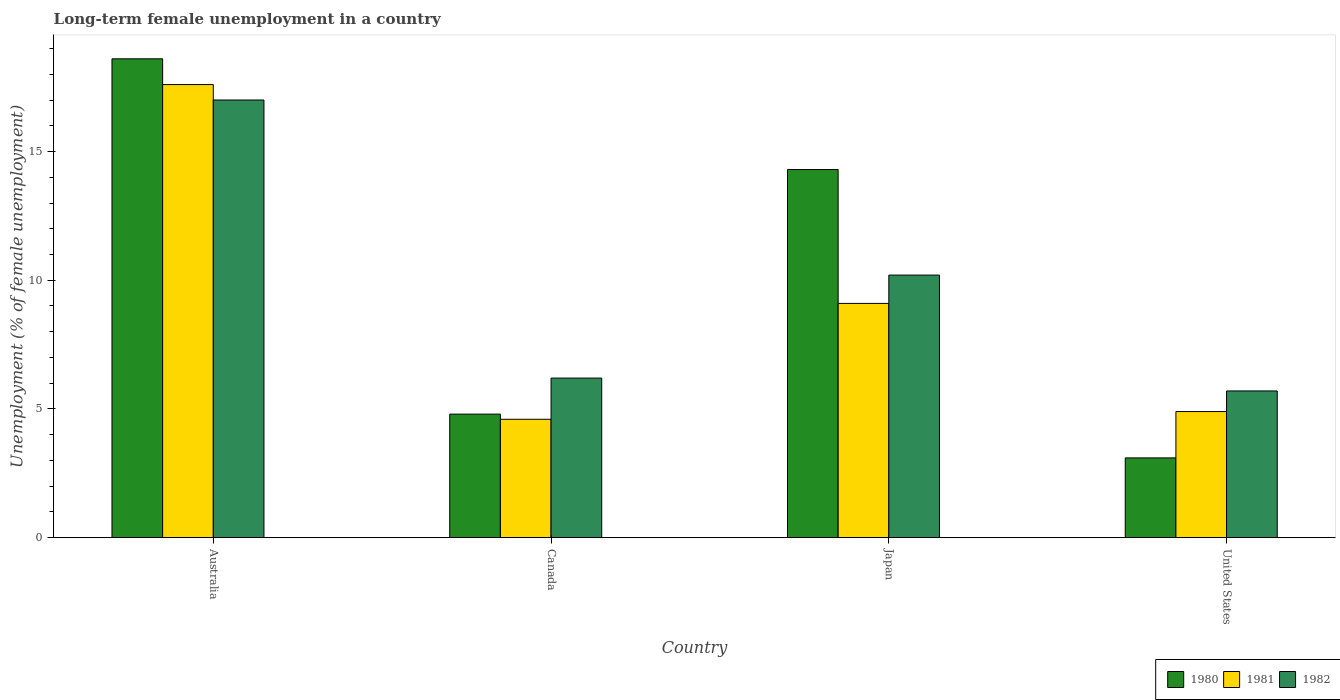Are the number of bars per tick equal to the number of legend labels?
Ensure brevity in your answer.  Yes. In how many cases, is the number of bars for a given country not equal to the number of legend labels?
Keep it short and to the point. 0. What is the percentage of long-term unemployed female population in 1980 in United States?
Offer a very short reply. 3.1. Across all countries, what is the minimum percentage of long-term unemployed female population in 1982?
Your answer should be very brief. 5.7. In which country was the percentage of long-term unemployed female population in 1982 minimum?
Provide a succinct answer. United States. What is the total percentage of long-term unemployed female population in 1982 in the graph?
Offer a terse response. 39.1. What is the difference between the percentage of long-term unemployed female population in 1980 in Canada and that in United States?
Provide a short and direct response. 1.7. What is the difference between the percentage of long-term unemployed female population in 1981 in Canada and the percentage of long-term unemployed female population in 1982 in Australia?
Provide a short and direct response. -12.4. What is the average percentage of long-term unemployed female population in 1982 per country?
Make the answer very short. 9.77. What is the difference between the percentage of long-term unemployed female population of/in 1982 and percentage of long-term unemployed female population of/in 1981 in Australia?
Ensure brevity in your answer.  -0.6. What is the ratio of the percentage of long-term unemployed female population in 1980 in Australia to that in United States?
Provide a short and direct response. 6. What is the difference between the highest and the second highest percentage of long-term unemployed female population in 1982?
Your answer should be very brief. 6.8. What is the difference between the highest and the lowest percentage of long-term unemployed female population in 1981?
Your response must be concise. 13. Is the sum of the percentage of long-term unemployed female population in 1982 in Canada and United States greater than the maximum percentage of long-term unemployed female population in 1980 across all countries?
Offer a terse response. No. What does the 3rd bar from the left in Japan represents?
Ensure brevity in your answer.  1982. Is it the case that in every country, the sum of the percentage of long-term unemployed female population in 1980 and percentage of long-term unemployed female population in 1981 is greater than the percentage of long-term unemployed female population in 1982?
Your response must be concise. Yes. How many bars are there?
Keep it short and to the point. 12. Does the graph contain grids?
Offer a very short reply. No. How many legend labels are there?
Your answer should be compact. 3. How are the legend labels stacked?
Your response must be concise. Horizontal. What is the title of the graph?
Provide a succinct answer. Long-term female unemployment in a country. What is the label or title of the Y-axis?
Provide a succinct answer. Unemployment (% of female unemployment). What is the Unemployment (% of female unemployment) in 1980 in Australia?
Keep it short and to the point. 18.6. What is the Unemployment (% of female unemployment) in 1981 in Australia?
Keep it short and to the point. 17.6. What is the Unemployment (% of female unemployment) in 1980 in Canada?
Provide a short and direct response. 4.8. What is the Unemployment (% of female unemployment) of 1981 in Canada?
Provide a short and direct response. 4.6. What is the Unemployment (% of female unemployment) in 1982 in Canada?
Your response must be concise. 6.2. What is the Unemployment (% of female unemployment) of 1980 in Japan?
Your answer should be very brief. 14.3. What is the Unemployment (% of female unemployment) of 1981 in Japan?
Provide a succinct answer. 9.1. What is the Unemployment (% of female unemployment) of 1982 in Japan?
Offer a terse response. 10.2. What is the Unemployment (% of female unemployment) in 1980 in United States?
Provide a succinct answer. 3.1. What is the Unemployment (% of female unemployment) of 1981 in United States?
Your answer should be compact. 4.9. What is the Unemployment (% of female unemployment) in 1982 in United States?
Provide a short and direct response. 5.7. Across all countries, what is the maximum Unemployment (% of female unemployment) in 1980?
Your answer should be compact. 18.6. Across all countries, what is the maximum Unemployment (% of female unemployment) in 1981?
Provide a succinct answer. 17.6. Across all countries, what is the minimum Unemployment (% of female unemployment) of 1980?
Give a very brief answer. 3.1. Across all countries, what is the minimum Unemployment (% of female unemployment) of 1981?
Make the answer very short. 4.6. Across all countries, what is the minimum Unemployment (% of female unemployment) in 1982?
Provide a short and direct response. 5.7. What is the total Unemployment (% of female unemployment) of 1980 in the graph?
Give a very brief answer. 40.8. What is the total Unemployment (% of female unemployment) of 1981 in the graph?
Your answer should be very brief. 36.2. What is the total Unemployment (% of female unemployment) of 1982 in the graph?
Offer a very short reply. 39.1. What is the difference between the Unemployment (% of female unemployment) of 1980 in Australia and that in Canada?
Keep it short and to the point. 13.8. What is the difference between the Unemployment (% of female unemployment) in 1982 in Australia and that in Canada?
Your response must be concise. 10.8. What is the difference between the Unemployment (% of female unemployment) in 1981 in Australia and that in Japan?
Your response must be concise. 8.5. What is the difference between the Unemployment (% of female unemployment) of 1982 in Australia and that in Japan?
Your answer should be compact. 6.8. What is the difference between the Unemployment (% of female unemployment) in 1981 in Australia and that in United States?
Offer a very short reply. 12.7. What is the difference between the Unemployment (% of female unemployment) of 1982 in Australia and that in United States?
Provide a short and direct response. 11.3. What is the difference between the Unemployment (% of female unemployment) of 1982 in Canada and that in Japan?
Keep it short and to the point. -4. What is the difference between the Unemployment (% of female unemployment) of 1980 in Canada and that in United States?
Offer a terse response. 1.7. What is the difference between the Unemployment (% of female unemployment) of 1982 in Canada and that in United States?
Offer a very short reply. 0.5. What is the difference between the Unemployment (% of female unemployment) in 1980 in Japan and that in United States?
Provide a succinct answer. 11.2. What is the difference between the Unemployment (% of female unemployment) in 1982 in Japan and that in United States?
Offer a very short reply. 4.5. What is the difference between the Unemployment (% of female unemployment) of 1980 in Australia and the Unemployment (% of female unemployment) of 1982 in Canada?
Ensure brevity in your answer.  12.4. What is the difference between the Unemployment (% of female unemployment) of 1980 in Australia and the Unemployment (% of female unemployment) of 1981 in Japan?
Offer a very short reply. 9.5. What is the difference between the Unemployment (% of female unemployment) of 1981 in Australia and the Unemployment (% of female unemployment) of 1982 in Japan?
Make the answer very short. 7.4. What is the difference between the Unemployment (% of female unemployment) of 1980 in Australia and the Unemployment (% of female unemployment) of 1981 in United States?
Offer a terse response. 13.7. What is the difference between the Unemployment (% of female unemployment) in 1980 in Australia and the Unemployment (% of female unemployment) in 1982 in United States?
Your answer should be compact. 12.9. What is the difference between the Unemployment (% of female unemployment) of 1981 in Australia and the Unemployment (% of female unemployment) of 1982 in United States?
Keep it short and to the point. 11.9. What is the difference between the Unemployment (% of female unemployment) in 1980 in Canada and the Unemployment (% of female unemployment) in 1981 in Japan?
Offer a terse response. -4.3. What is the difference between the Unemployment (% of female unemployment) of 1981 in Canada and the Unemployment (% of female unemployment) of 1982 in Japan?
Keep it short and to the point. -5.6. What is the difference between the Unemployment (% of female unemployment) in 1980 in Canada and the Unemployment (% of female unemployment) in 1981 in United States?
Your answer should be very brief. -0.1. What is the difference between the Unemployment (% of female unemployment) of 1980 in Canada and the Unemployment (% of female unemployment) of 1982 in United States?
Give a very brief answer. -0.9. What is the difference between the Unemployment (% of female unemployment) in 1981 in Japan and the Unemployment (% of female unemployment) in 1982 in United States?
Your answer should be very brief. 3.4. What is the average Unemployment (% of female unemployment) of 1980 per country?
Provide a short and direct response. 10.2. What is the average Unemployment (% of female unemployment) in 1981 per country?
Offer a very short reply. 9.05. What is the average Unemployment (% of female unemployment) in 1982 per country?
Provide a succinct answer. 9.78. What is the difference between the Unemployment (% of female unemployment) of 1980 and Unemployment (% of female unemployment) of 1982 in Canada?
Your answer should be very brief. -1.4. What is the difference between the Unemployment (% of female unemployment) of 1981 and Unemployment (% of female unemployment) of 1982 in Canada?
Your answer should be very brief. -1.6. What is the difference between the Unemployment (% of female unemployment) in 1980 and Unemployment (% of female unemployment) in 1981 in Japan?
Make the answer very short. 5.2. What is the difference between the Unemployment (% of female unemployment) of 1980 and Unemployment (% of female unemployment) of 1982 in Japan?
Provide a short and direct response. 4.1. What is the difference between the Unemployment (% of female unemployment) of 1981 and Unemployment (% of female unemployment) of 1982 in Japan?
Make the answer very short. -1.1. What is the difference between the Unemployment (% of female unemployment) of 1980 and Unemployment (% of female unemployment) of 1982 in United States?
Offer a terse response. -2.6. What is the difference between the Unemployment (% of female unemployment) in 1981 and Unemployment (% of female unemployment) in 1982 in United States?
Your response must be concise. -0.8. What is the ratio of the Unemployment (% of female unemployment) in 1980 in Australia to that in Canada?
Offer a terse response. 3.88. What is the ratio of the Unemployment (% of female unemployment) of 1981 in Australia to that in Canada?
Offer a terse response. 3.83. What is the ratio of the Unemployment (% of female unemployment) of 1982 in Australia to that in Canada?
Ensure brevity in your answer.  2.74. What is the ratio of the Unemployment (% of female unemployment) of 1980 in Australia to that in Japan?
Your answer should be compact. 1.3. What is the ratio of the Unemployment (% of female unemployment) of 1981 in Australia to that in Japan?
Give a very brief answer. 1.93. What is the ratio of the Unemployment (% of female unemployment) of 1982 in Australia to that in Japan?
Your answer should be very brief. 1.67. What is the ratio of the Unemployment (% of female unemployment) in 1981 in Australia to that in United States?
Your response must be concise. 3.59. What is the ratio of the Unemployment (% of female unemployment) in 1982 in Australia to that in United States?
Your answer should be very brief. 2.98. What is the ratio of the Unemployment (% of female unemployment) in 1980 in Canada to that in Japan?
Provide a succinct answer. 0.34. What is the ratio of the Unemployment (% of female unemployment) of 1981 in Canada to that in Japan?
Make the answer very short. 0.51. What is the ratio of the Unemployment (% of female unemployment) of 1982 in Canada to that in Japan?
Make the answer very short. 0.61. What is the ratio of the Unemployment (% of female unemployment) in 1980 in Canada to that in United States?
Ensure brevity in your answer.  1.55. What is the ratio of the Unemployment (% of female unemployment) in 1981 in Canada to that in United States?
Keep it short and to the point. 0.94. What is the ratio of the Unemployment (% of female unemployment) of 1982 in Canada to that in United States?
Keep it short and to the point. 1.09. What is the ratio of the Unemployment (% of female unemployment) in 1980 in Japan to that in United States?
Provide a short and direct response. 4.61. What is the ratio of the Unemployment (% of female unemployment) in 1981 in Japan to that in United States?
Give a very brief answer. 1.86. What is the ratio of the Unemployment (% of female unemployment) in 1982 in Japan to that in United States?
Offer a very short reply. 1.79. What is the difference between the highest and the second highest Unemployment (% of female unemployment) in 1980?
Ensure brevity in your answer.  4.3. What is the difference between the highest and the second highest Unemployment (% of female unemployment) of 1981?
Provide a short and direct response. 8.5. What is the difference between the highest and the lowest Unemployment (% of female unemployment) in 1982?
Your answer should be very brief. 11.3. 